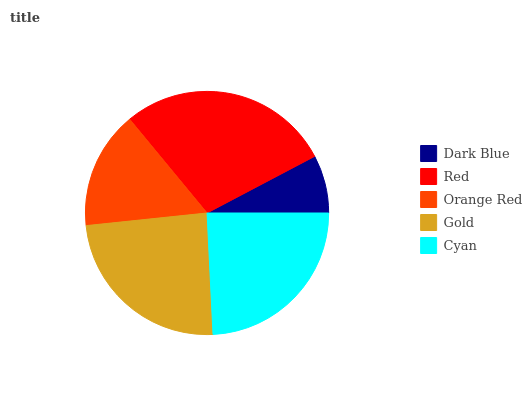Is Dark Blue the minimum?
Answer yes or no. Yes. Is Red the maximum?
Answer yes or no. Yes. Is Orange Red the minimum?
Answer yes or no. No. Is Orange Red the maximum?
Answer yes or no. No. Is Red greater than Orange Red?
Answer yes or no. Yes. Is Orange Red less than Red?
Answer yes or no. Yes. Is Orange Red greater than Red?
Answer yes or no. No. Is Red less than Orange Red?
Answer yes or no. No. Is Gold the high median?
Answer yes or no. Yes. Is Gold the low median?
Answer yes or no. Yes. Is Red the high median?
Answer yes or no. No. Is Red the low median?
Answer yes or no. No. 